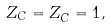Convert formula to latex. <formula><loc_0><loc_0><loc_500><loc_500>Z _ { C } = Z _ { \bar { C } } = 1 ,</formula> 